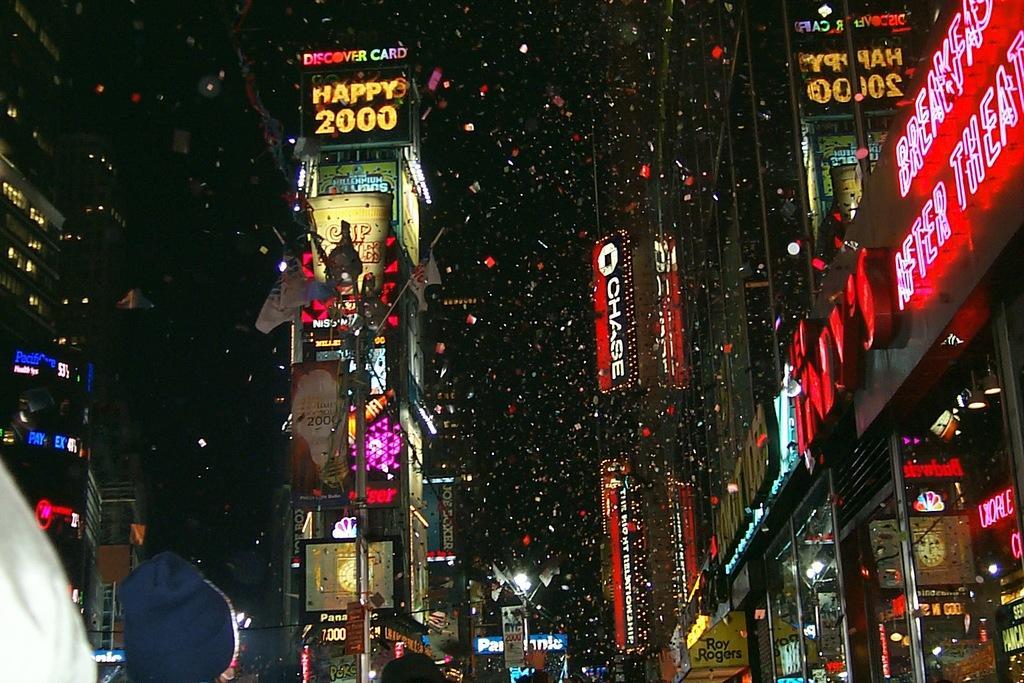Could you give a brief overview of what you see in this image? In this picture I can see buildings, there are flags with the poles, there are poles, lights, boards, and there is dark background. 